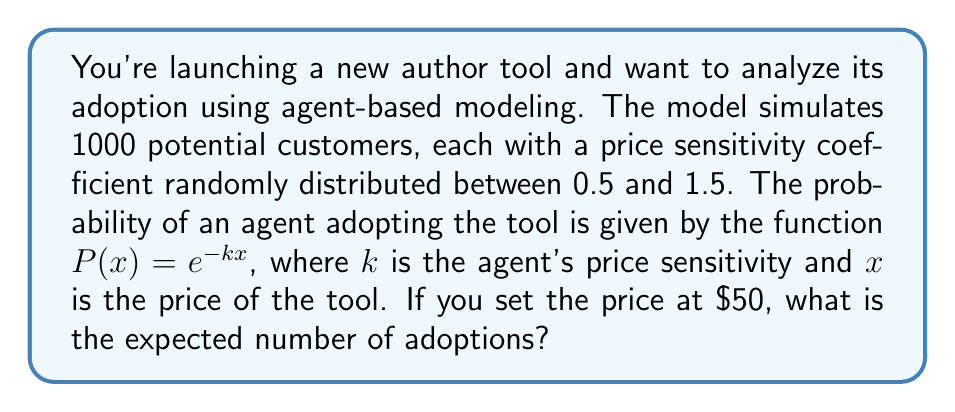Help me with this question. To solve this problem, we'll follow these steps:

1) The price sensitivity coefficient $k$ is uniformly distributed between 0.5 and 1.5.

2) For each agent, the probability of adoption is $P(x) = e^{-kx}$, where $x = 50$ (the price).

3) To find the expected number of adoptions, we need to calculate the average probability of adoption and multiply it by the total number of agents.

4) The average probability can be calculated by integrating the probability function over the distribution of $k$:

   $$\bar{P} = \frac{1}{1.5 - 0.5} \int_{0.5}^{1.5} e^{-50k} dk$$

5) Solving this integral:

   $$\bar{P} = \frac{1}{1} \left[-\frac{1}{50}e^{-50k}\right]_{0.5}^{1.5}$$
   
   $$= -\frac{1}{50}(e^{-75} - e^{-25})$$

6) Calculate this value:

   $$\bar{P} \approx 0.0388$$

7) The expected number of adoptions is this probability multiplied by the total number of agents:

   $$E(\text{adoptions}) = 1000 \times 0.0388 \approx 38.8$$
Answer: 39 adoptions 